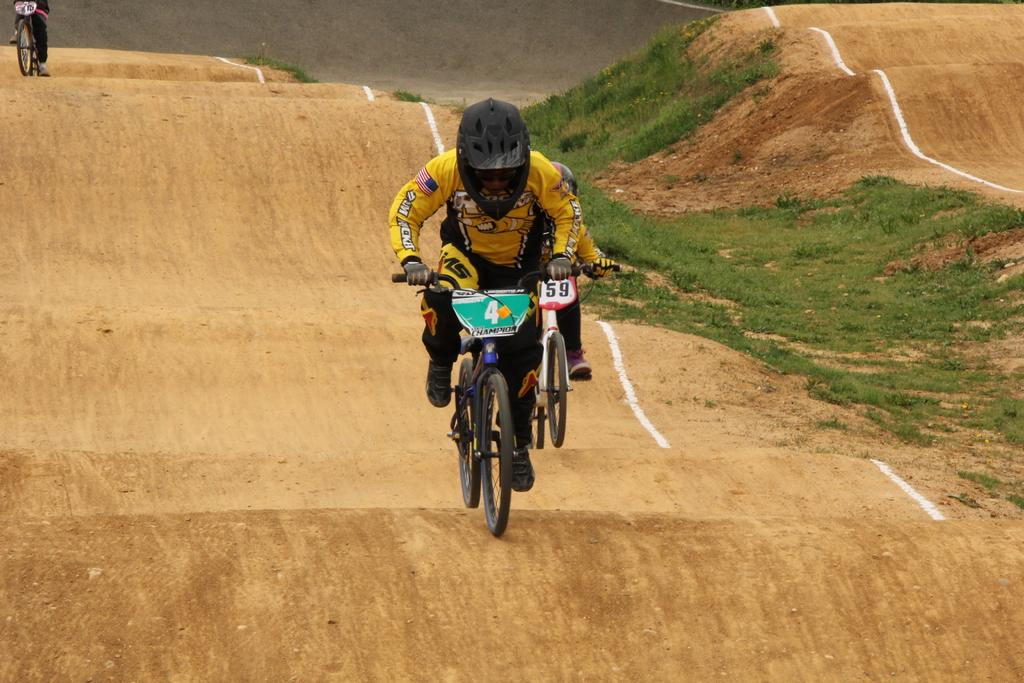What are the people in the image doing? The people in the image are riding bicycles. What is the surface they are riding on? There is a cycling track at the bottom of the image. What can be seen in the background of the image? There is a road visible in the background of the image. What type of vegetation is present in the image? There is grass in the image. What color is the chalk used to draw on the weight in the image? There is no chalk or weight present in the image; it features people riding bicycles on a cycling track. 